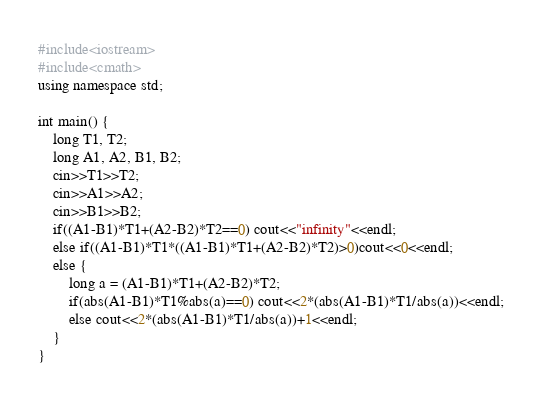<code> <loc_0><loc_0><loc_500><loc_500><_C++_>#include<iostream>
#include<cmath>
using namespace std;

int main() {
    long T1, T2;
    long A1, A2, B1, B2;
    cin>>T1>>T2;
    cin>>A1>>A2;
    cin>>B1>>B2;
    if((A1-B1)*T1+(A2-B2)*T2==0) cout<<"infinity"<<endl;
    else if((A1-B1)*T1*((A1-B1)*T1+(A2-B2)*T2)>0)cout<<0<<endl;
    else {
        long a = (A1-B1)*T1+(A2-B2)*T2;
        if(abs(A1-B1)*T1%abs(a)==0) cout<<2*(abs(A1-B1)*T1/abs(a))<<endl;
        else cout<<2*(abs(A1-B1)*T1/abs(a))+1<<endl;
    }
}
</code> 